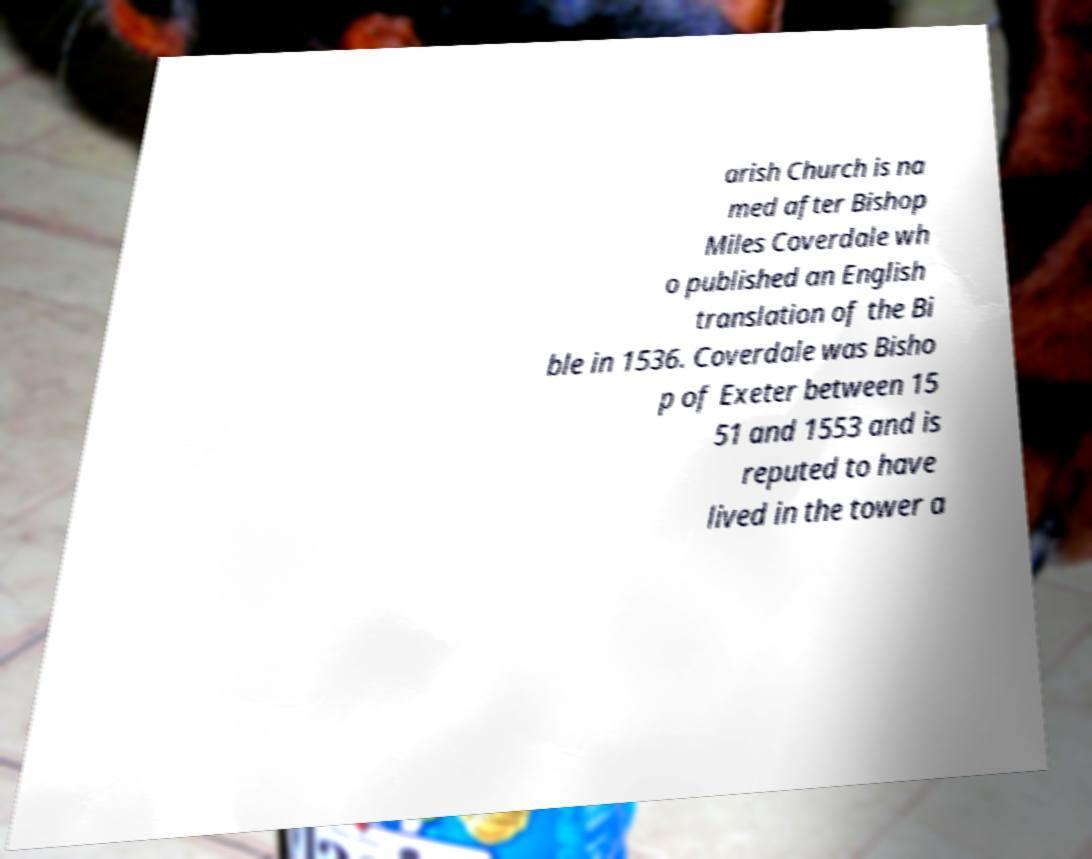Could you assist in decoding the text presented in this image and type it out clearly? arish Church is na med after Bishop Miles Coverdale wh o published an English translation of the Bi ble in 1536. Coverdale was Bisho p of Exeter between 15 51 and 1553 and is reputed to have lived in the tower a 